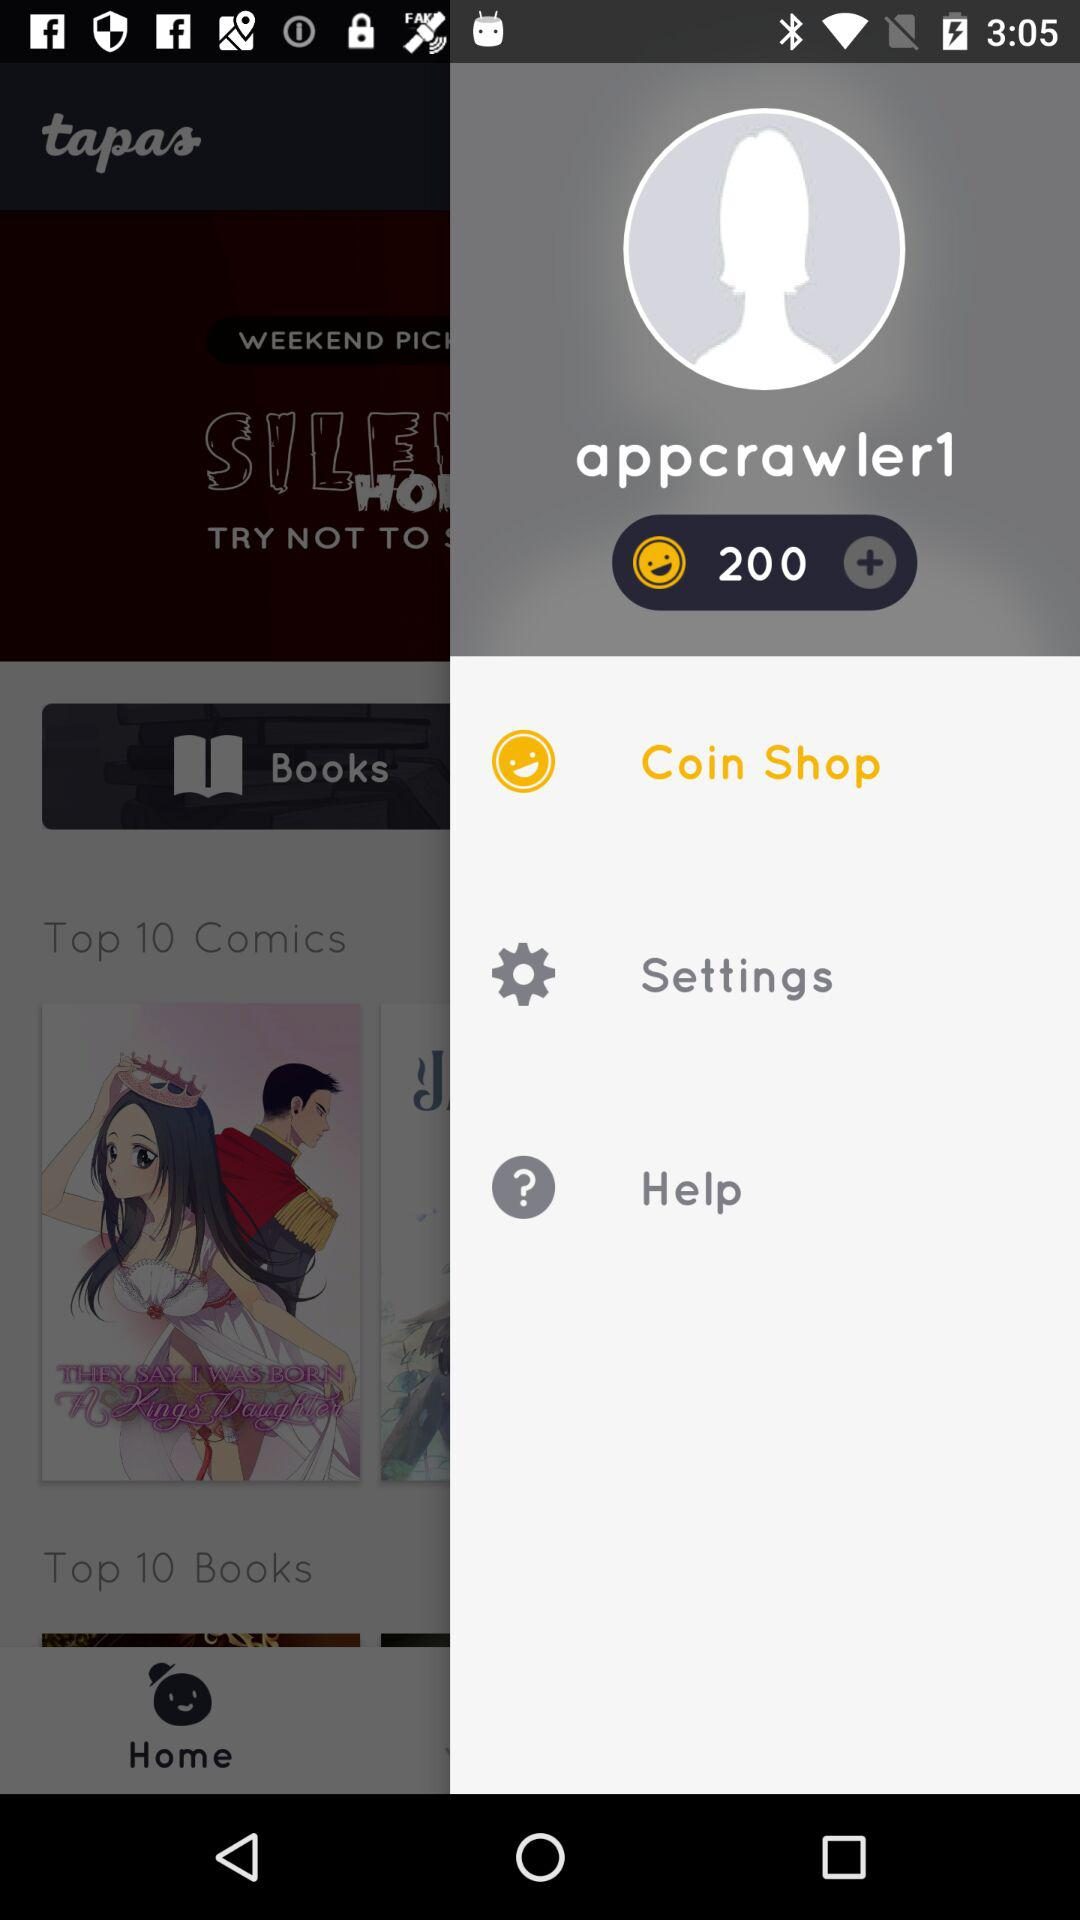How many notifications are there in "Settings"?
When the provided information is insufficient, respond with <no answer>. <no answer> 